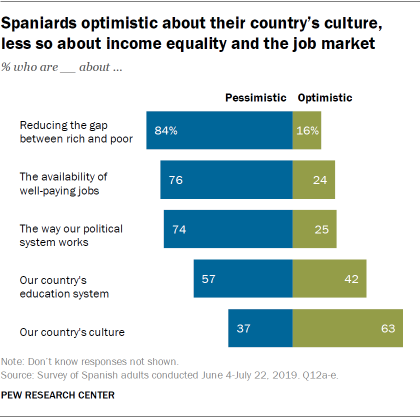Draw attention to some important aspects in this diagram. The median value of the green bar is 25. The highest value of the blue bar is 84. 